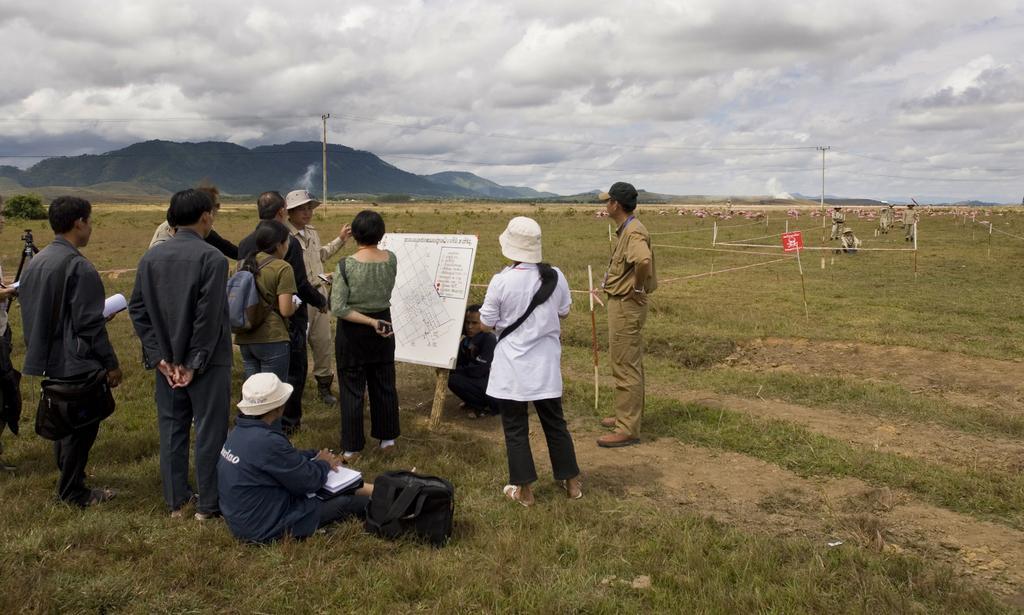Please provide a concise description of this image. In this image there are a few people standing and one person is sitting on the surface of the grass, in front of them there is a board. On the right side of the image there are few people. In the background there is a mountain and a sky. 